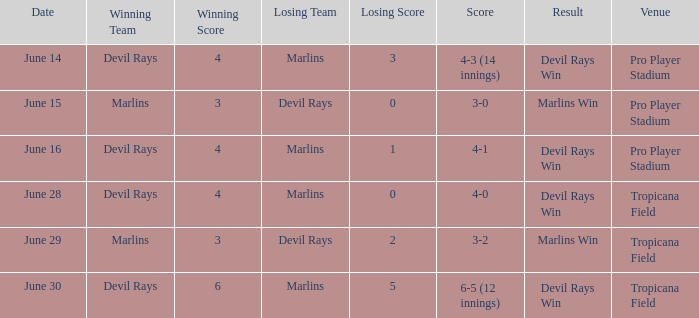Who won by a score of 4-1? Devil Rays. 